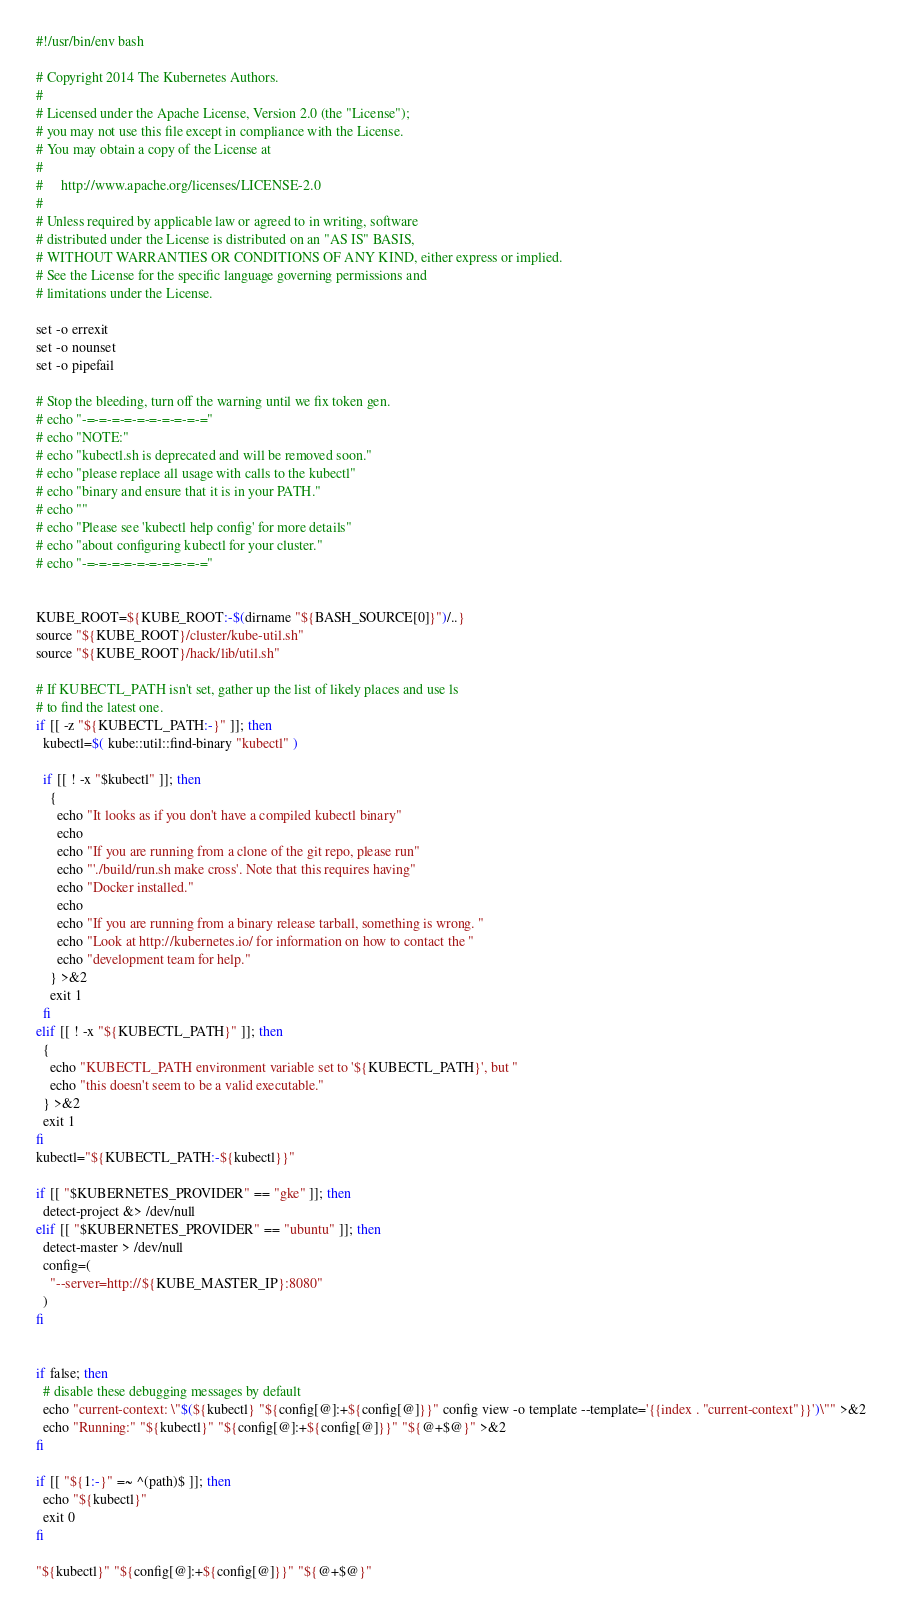Convert code to text. <code><loc_0><loc_0><loc_500><loc_500><_Bash_>#!/usr/bin/env bash

# Copyright 2014 The Kubernetes Authors.
#
# Licensed under the Apache License, Version 2.0 (the "License");
# you may not use this file except in compliance with the License.
# You may obtain a copy of the License at
#
#     http://www.apache.org/licenses/LICENSE-2.0
#
# Unless required by applicable law or agreed to in writing, software
# distributed under the License is distributed on an "AS IS" BASIS,
# WITHOUT WARRANTIES OR CONDITIONS OF ANY KIND, either express or implied.
# See the License for the specific language governing permissions and
# limitations under the License.

set -o errexit
set -o nounset
set -o pipefail

# Stop the bleeding, turn off the warning until we fix token gen.
# echo "-=-=-=-=-=-=-=-=-=-="
# echo "NOTE:"
# echo "kubectl.sh is deprecated and will be removed soon."
# echo "please replace all usage with calls to the kubectl"
# echo "binary and ensure that it is in your PATH."
# echo ""
# echo "Please see 'kubectl help config' for more details"
# echo "about configuring kubectl for your cluster."
# echo "-=-=-=-=-=-=-=-=-=-="


KUBE_ROOT=${KUBE_ROOT:-$(dirname "${BASH_SOURCE[0]}")/..}
source "${KUBE_ROOT}/cluster/kube-util.sh"
source "${KUBE_ROOT}/hack/lib/util.sh"

# If KUBECTL_PATH isn't set, gather up the list of likely places and use ls
# to find the latest one.
if [[ -z "${KUBECTL_PATH:-}" ]]; then
  kubectl=$( kube::util::find-binary "kubectl" )

  if [[ ! -x "$kubectl" ]]; then
    {
      echo "It looks as if you don't have a compiled kubectl binary"
      echo
      echo "If you are running from a clone of the git repo, please run"
      echo "'./build/run.sh make cross'. Note that this requires having"
      echo "Docker installed."
      echo
      echo "If you are running from a binary release tarball, something is wrong. "
      echo "Look at http://kubernetes.io/ for information on how to contact the "
      echo "development team for help."
    } >&2
    exit 1
  fi
elif [[ ! -x "${KUBECTL_PATH}" ]]; then
  {
    echo "KUBECTL_PATH environment variable set to '${KUBECTL_PATH}', but "
    echo "this doesn't seem to be a valid executable."
  } >&2
  exit 1
fi
kubectl="${KUBECTL_PATH:-${kubectl}}"

if [[ "$KUBERNETES_PROVIDER" == "gke" ]]; then
  detect-project &> /dev/null
elif [[ "$KUBERNETES_PROVIDER" == "ubuntu" ]]; then
  detect-master > /dev/null
  config=(
    "--server=http://${KUBE_MASTER_IP}:8080"
  )
fi


if false; then
  # disable these debugging messages by default
  echo "current-context: \"$(${kubectl} "${config[@]:+${config[@]}}" config view -o template --template='{{index . "current-context"}}')\"" >&2
  echo "Running:" "${kubectl}" "${config[@]:+${config[@]}}" "${@+$@}" >&2
fi

if [[ "${1:-}" =~ ^(path)$ ]]; then
  echo "${kubectl}"
  exit 0
fi

"${kubectl}" "${config[@]:+${config[@]}}" "${@+$@}"

</code> 